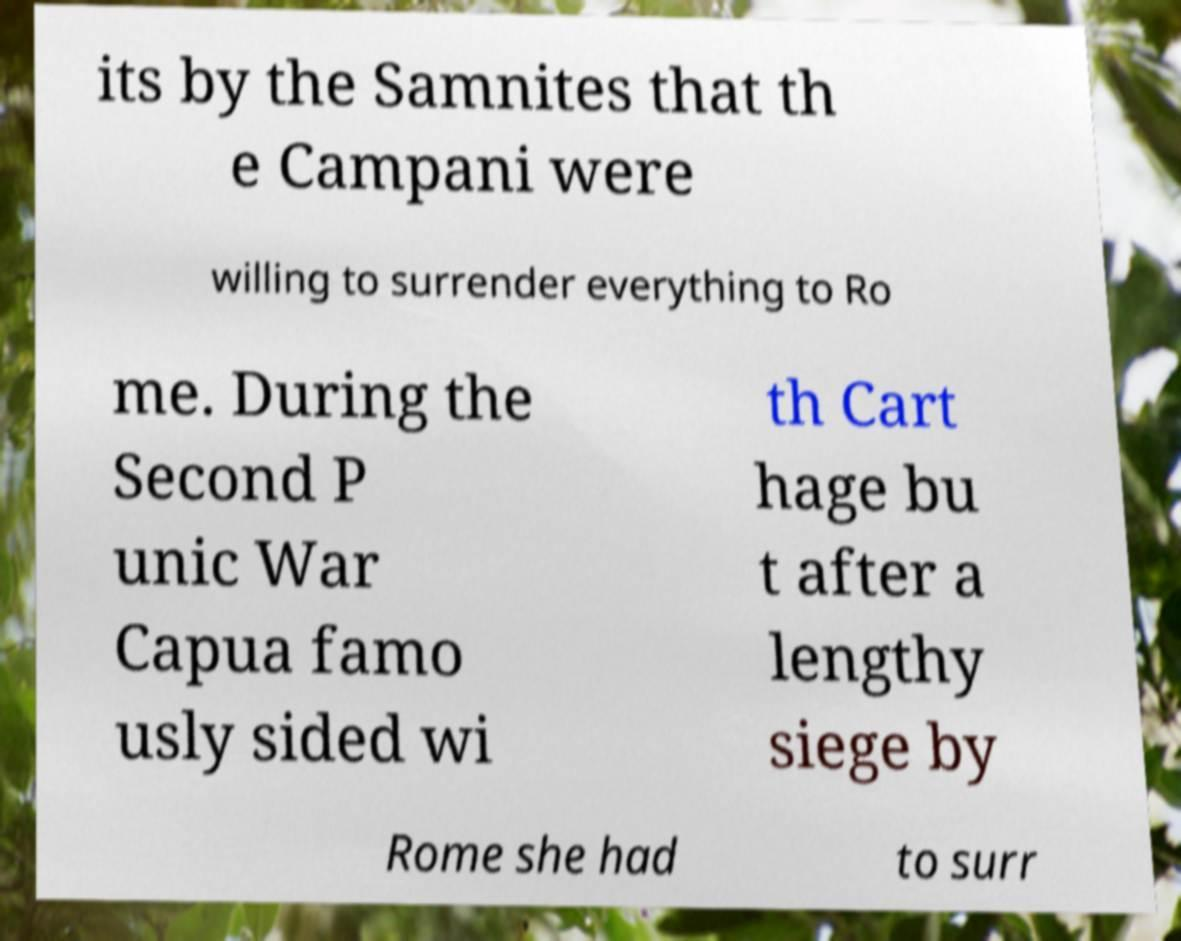Please read and relay the text visible in this image. What does it say? its by the Samnites that th e Campani were willing to surrender everything to Ro me. During the Second P unic War Capua famo usly sided wi th Cart hage bu t after a lengthy siege by Rome she had to surr 